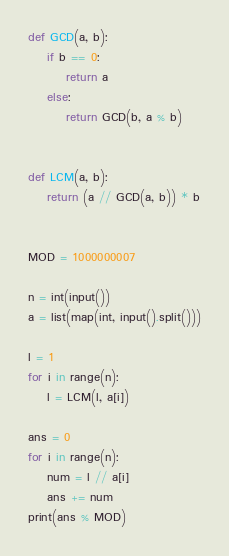<code> <loc_0><loc_0><loc_500><loc_500><_Python_>def GCD(a, b):
    if b == 0:
        return a
    else:
        return GCD(b, a % b)


def LCM(a, b):
    return (a // GCD(a, b)) * b


MOD = 1000000007

n = int(input())
a = list(map(int, input().split()))

l = 1
for i in range(n):
    l = LCM(l, a[i])

ans = 0
for i in range(n):
    num = l // a[i]
    ans += num
print(ans % MOD)
</code> 